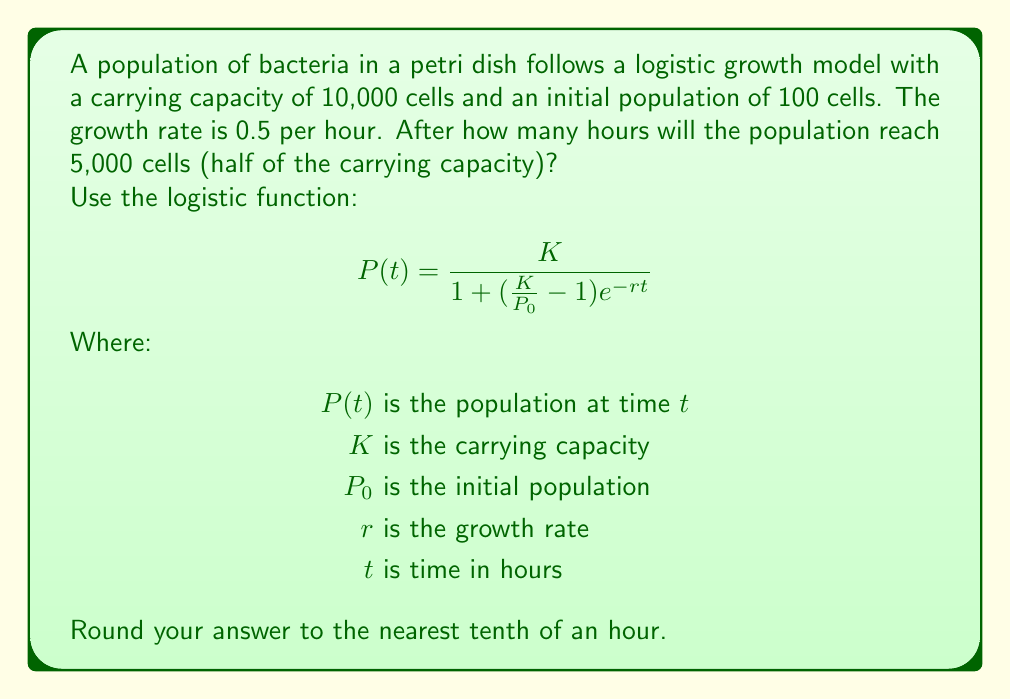What is the answer to this math problem? To solve this problem, we'll use the logistic function and solve for $t$ when $P(t) = 5,000$.

1. Given information:
   $K = 10,000$
   $P_0 = 100$
   $r = 0.5$
   $P(t) = 5,000$

2. Substitute these values into the logistic function:

   $$5000 = \frac{10000}{1 + (\frac{10000}{100} - 1)e^{-0.5t}}$$

3. Simplify:

   $$5000 = \frac{10000}{1 + 99e^{-0.5t}}$$

4. Multiply both sides by the denominator:

   $$5000(1 + 99e^{-0.5t}) = 10000$$

5. Distribute:

   $$5000 + 495000e^{-0.5t} = 10000$$

6. Subtract 5000 from both sides:

   $$495000e^{-0.5t} = 5000$$

7. Divide both sides by 495000:

   $$e^{-0.5t} = \frac{1}{99}$$

8. Take the natural log of both sides:

   $$-0.5t = \ln(\frac{1}{99})$$

9. Divide both sides by -0.5:

   $$t = -\frac{2\ln(\frac{1}{99})}{1} = 2\ln(99)$$

10. Calculate the result:

    $$t \approx 9.2103$$

11. Round to the nearest tenth:

    $$t \approx 9.2 \text{ hours}$$
Answer: 9.2 hours 